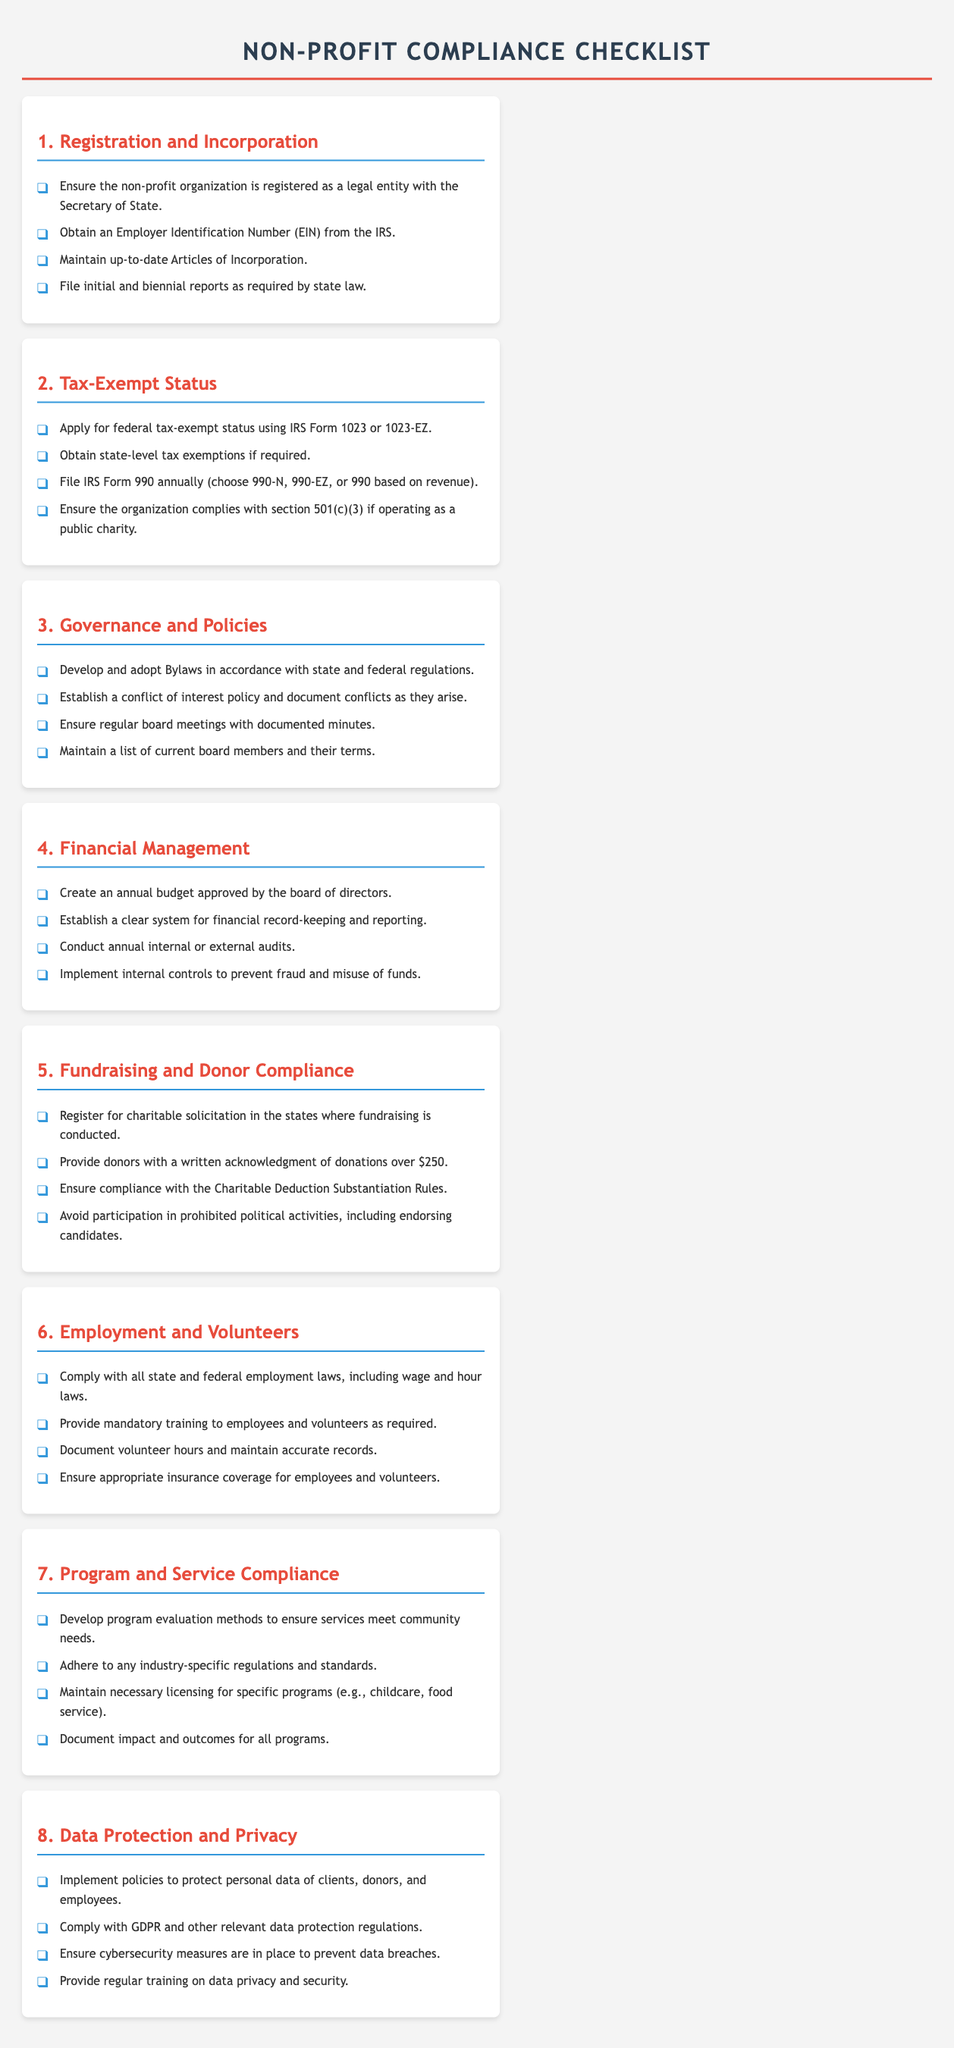what is the first item in the Registration and Incorporation section? The first item in this section is about ensuring the organization is registered as a legal entity.
Answer: Ensure the non-profit organization is registered as a legal entity with the Secretary of State how often should IRS Form 990 be filed? The document specifies that IRS Form 990 should be filed annually.
Answer: Annually how many sections are in the Non-Profit Compliance Checklist? The document contains a total of eight sections.
Answer: Eight what form is used to apply for federal tax-exempt status? The document mentions IRS Form 1023 or 1023-EZ for applying for federal tax-exempt status.
Answer: IRS Form 1023 or 1023-EZ which section covers financial management practices? The section that addresses financial management practices is labeled as Financial Management.
Answer: Financial Management what is one requirement under Employment and Volunteers? Compliance with state and federal employment laws is a necessity mentioned in this section.
Answer: Comply with all state and federal employment laws, including wage and hour laws which section requires developing program evaluation methods? Program and Service Compliance requires developing program evaluation methods.
Answer: Program and Service Compliance what is the purpose of the conflict of interest policy? The document states that the conflict of interest policy is meant to document conflicts as they arise.
Answer: Document conflicts as they arise 